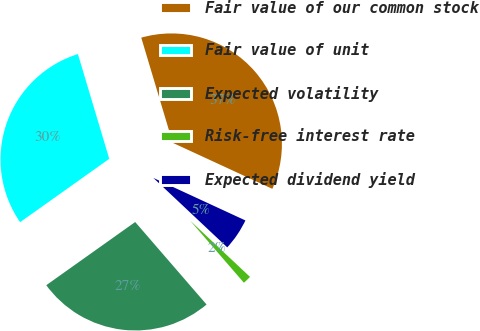<chart> <loc_0><loc_0><loc_500><loc_500><pie_chart><fcel>Fair value of our common stock<fcel>Fair value of unit<fcel>Expected volatility<fcel>Risk-free interest rate<fcel>Expected dividend yield<nl><fcel>36.52%<fcel>30.21%<fcel>26.52%<fcel>1.64%<fcel>5.12%<nl></chart> 